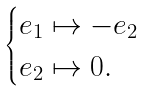Convert formula to latex. <formula><loc_0><loc_0><loc_500><loc_500>\begin{cases} e _ { 1 } \mapsto - e _ { 2 } \\ e _ { 2 } \mapsto 0 . \end{cases}</formula> 